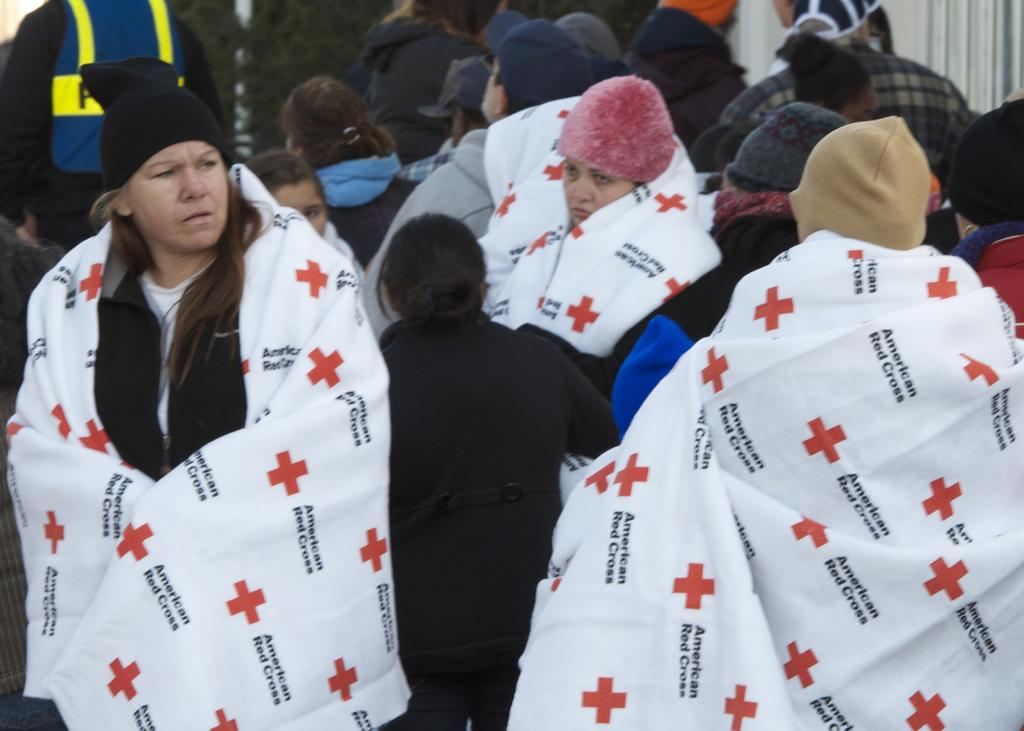How many people are present in the image? There are a few people in the image. What type of ship can be seen in the image? There is no ship present in the image; it only features a few people. What happens when the crown bursts in the image? There is no crown or bursting event depicted in the image. 